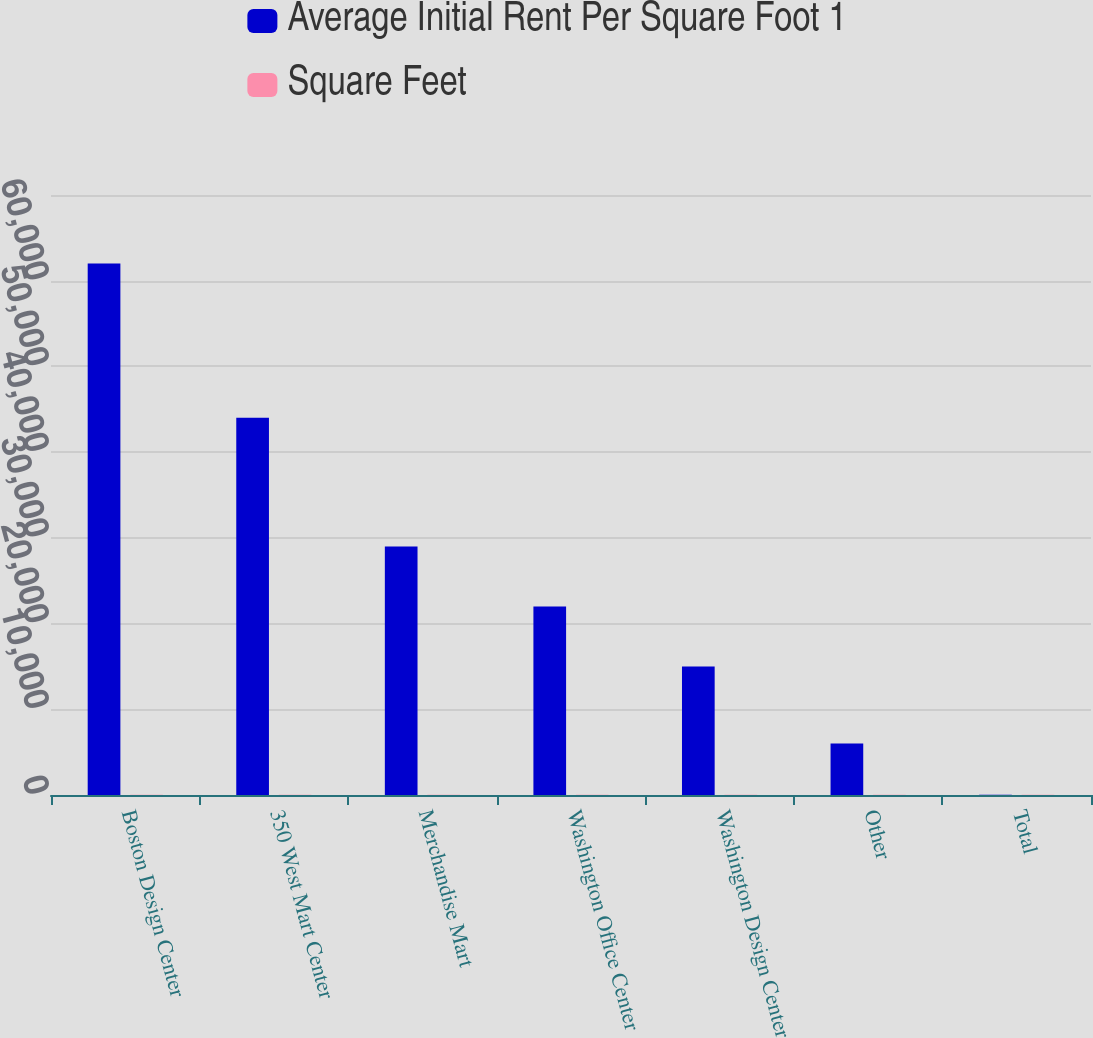Convert chart. <chart><loc_0><loc_0><loc_500><loc_500><stacked_bar_chart><ecel><fcel>Boston Design Center<fcel>350 West Mart Center<fcel>Merchandise Mart<fcel>Washington Office Center<fcel>Washington Design Center<fcel>Other<fcel>Total<nl><fcel>Average Initial Rent Per Square Foot 1<fcel>62000<fcel>44000<fcel>29000<fcel>22000<fcel>15000<fcel>6000<fcel>40.25<nl><fcel>Square Feet<fcel>20.35<fcel>18.23<fcel>23.04<fcel>40.25<fcel>38.46<fcel>17.75<fcel>24.24<nl></chart> 